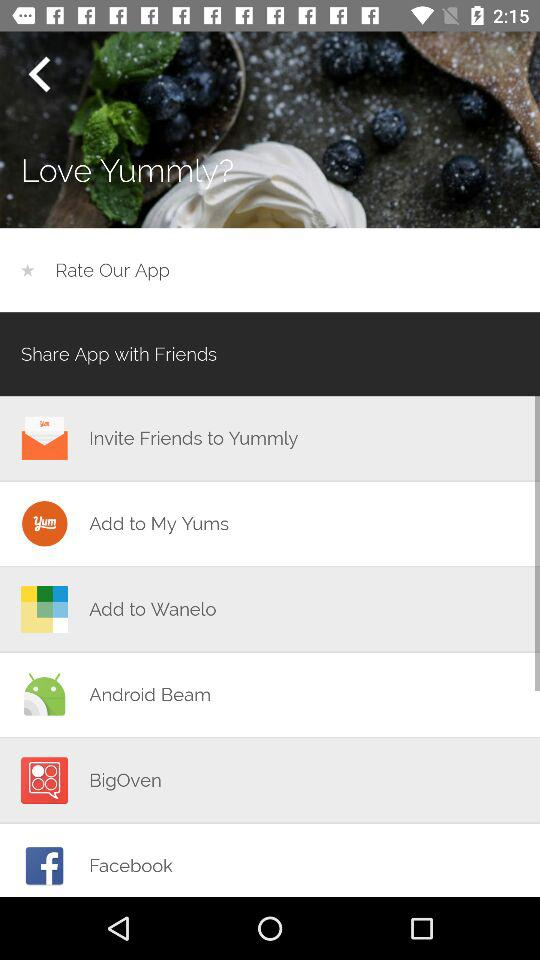On which application can I share the app? You can share the app on "Add to My Yums", "Add to Wanelo", "Android Beam", "BigOven" and "Facebook". 